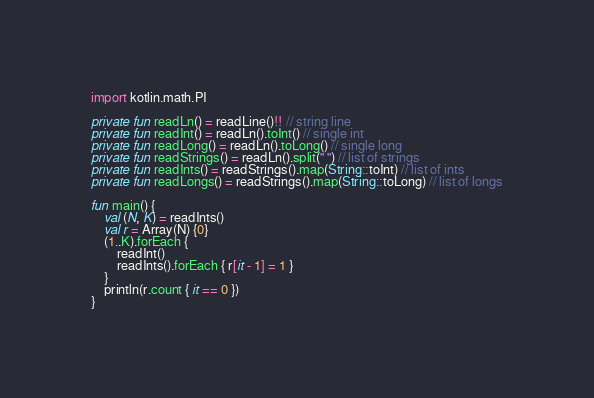<code> <loc_0><loc_0><loc_500><loc_500><_Kotlin_>import kotlin.math.PI

private fun readLn() = readLine()!! // string line
private fun readInt() = readLn().toInt() // single int
private fun readLong() = readLn().toLong() // single long
private fun readStrings() = readLn().split(" ") // list of strings
private fun readInts() = readStrings().map(String::toInt) // list of ints
private fun readLongs() = readStrings().map(String::toLong) // list of longs

fun main() {
    val (N, K) = readInts()
    val r = Array(N) {0}
    (1..K).forEach {
        readInt()
        readInts().forEach { r[it - 1] = 1 }
    }
    println(r.count { it == 0 })
}
</code> 